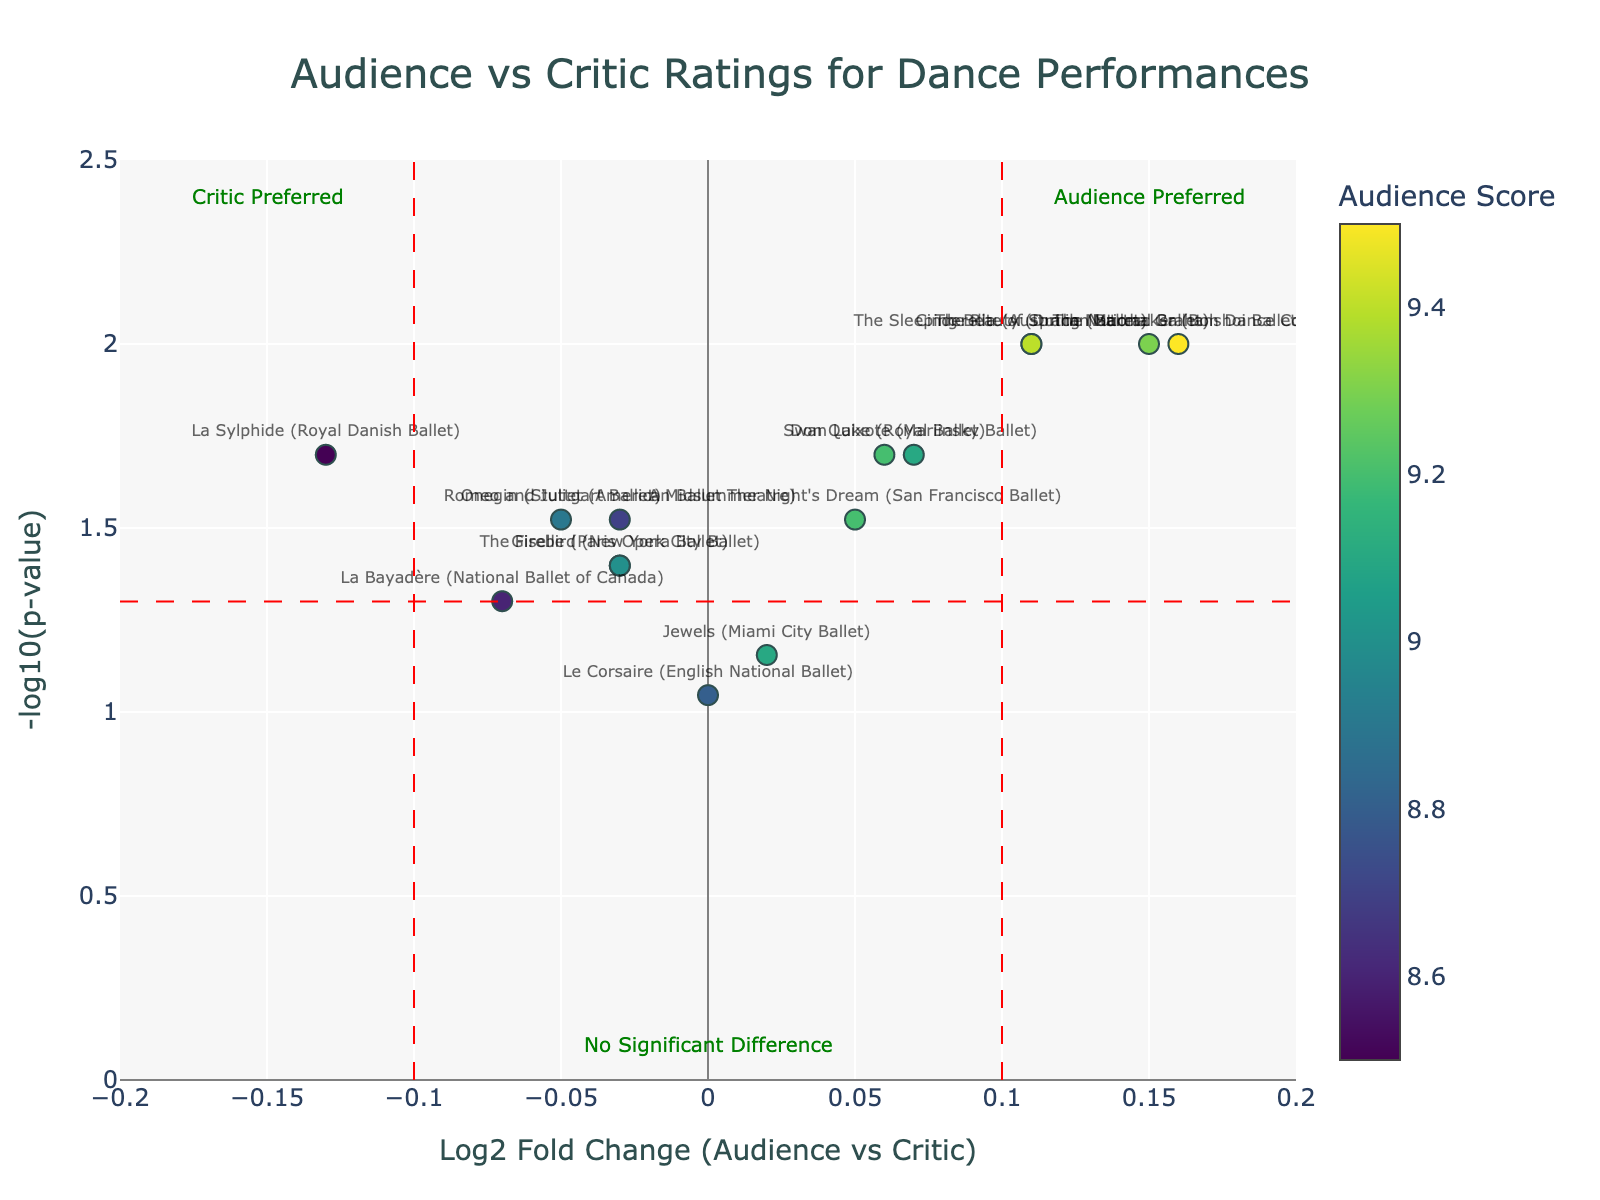What is the title of the plot? The title is the text located at the top center of the figure that describes what the plot is about. In this case, it describes the comparison of audience and critic ratings for dance performances.
Answer: Audience vs Critic Ratings for Dance Performances What does the y-axis represent? The y-axis represents the transformed p-values using a logarithmic scale. Specifically, it shows the negative logarithm (base 10) of the p-values.
Answer: -log10(p-value) Which dance performance has the highest audience score? The dance performance with the highest audience score can be identified by looking at the color scale on the markers. The performance labeled "The Nutcracker (Bolshoi Ballet)" has the highest audience score.
Answer: The Nutcracker (Bolshoi Ballet) How many dance performances have a log2 fold change greater than 0.1? Look at the x-axis and count the points that are to the right of the vertical red dashed line at x=0.1. The performances above this value are "The Nutcracker (Bolshoi Ballet)", "Cinderella (Australian Ballet)", "The Sleeping Beauty (Dutch National Ballet)", and "The Rite of Spring (Martha Graham Dance Company)" totaling four.
Answer: 4 What is the log2 fold change and -log10(p-value) for "Swan Lake (Royal Ballet)"? Locate "Swan Lake (Royal Ballet)" on the plot and refer to its x and y coordinates. The x value (log2 fold change) is 0.06 and the y value (-log10(p-value)) is 1.70.
Answer: log2 fold change: 0.06, -log10(p-value): 1.70 Which performance shows the most significant preference by critics? The most significant preference by critics is indicated by the lowest log2 fold change and highest -log10(p-value). "La Sylphide (Royal Danish Ballet)" has the lowest log2 fold change of -0.13 and a -log10(p-value) of 1.70, indicating significant critic preference.
Answer: La Sylphide (Royal Danish Ballet) What is the main observation you can make about the majority of performances? Most performances are clustered near the center of the plot, indicating that the log2 fold change between audience and critic ratings is very small and the p-values are not extremely low, showing there is no significant difference for most performances.
Answer: No significant difference for most performances Which performance is annotated as "Audience Preferred"? Look at the labels indicating "Audience Preferred" on the figure near x=0.15 on the x-axis. The performances to the right of this label are preferred by the audience. "The Nutcracker (Bolshoi Ballet)" is directly under this category.
Answer: The Nutcracker (Bolshoi Ballet) How many performances are considered as having no significant difference between audience and critic ratings? Performances with no significant difference are within the vertical lines at x=-0.1 and x=0.1 and below the horizontal line at y=1.3. Count the points in this region: "Swan Lake (Royal Ballet)", "Giselle (Paris Opera Ballet)", "Romeo and Juliet (American Ballet Theatre)", "Don Quixote (Mariinsky Ballet)", "La Bayadère (National Ballet of Canada)", "The Firebird (New York City Ballet)", "Le Corsaire (English National Ballet)", "A Midsummer Night's Dream (San Francisco Ballet)", "Jewels (Miami City Ballet)", "Onegin (Stuttgart Ballet)" making 10 performances.
Answer: 10 